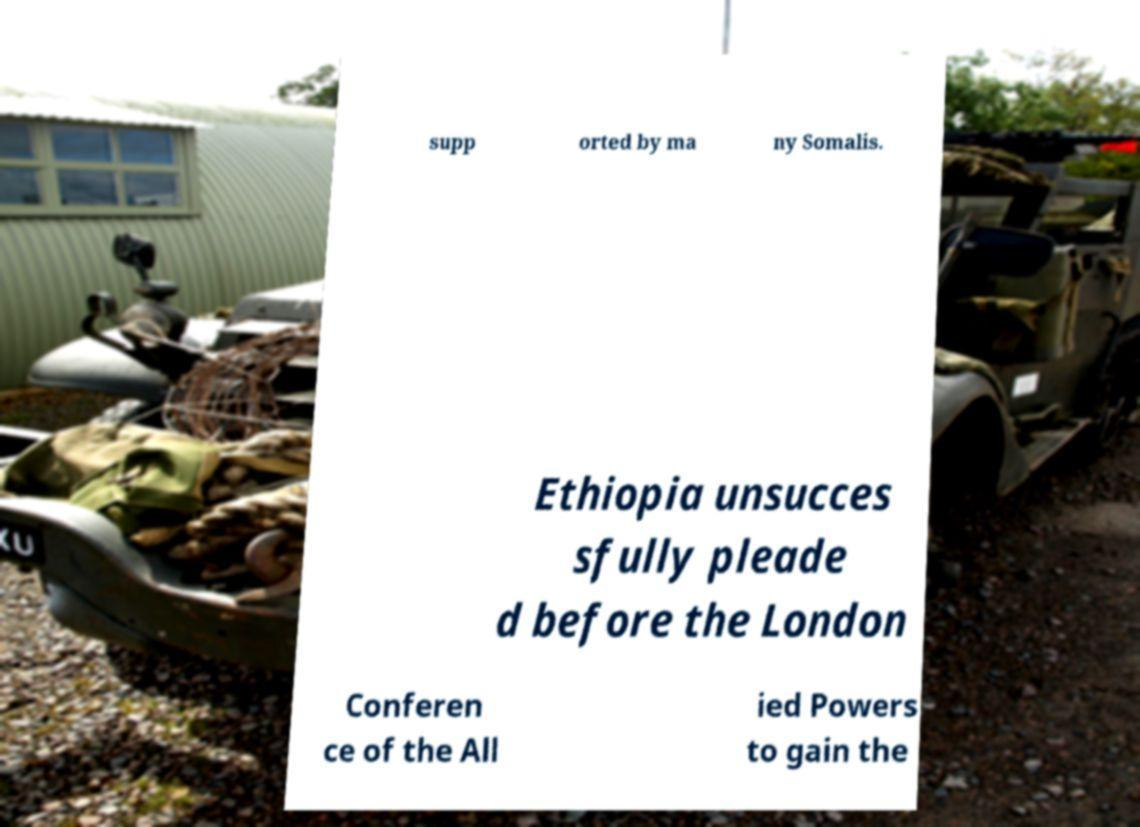Please read and relay the text visible in this image. What does it say? supp orted by ma ny Somalis. Ethiopia unsucces sfully pleade d before the London Conferen ce of the All ied Powers to gain the 